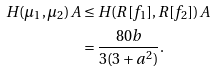Convert formula to latex. <formula><loc_0><loc_0><loc_500><loc_500>H ( \mu _ { 1 } , \mu _ { 2 } ) A & \leq H ( R [ f _ { 1 } ] , R [ f _ { 2 } ] ) A \\ & = \frac { 8 0 b } { 3 ( 3 + a ^ { 2 } ) } .</formula> 